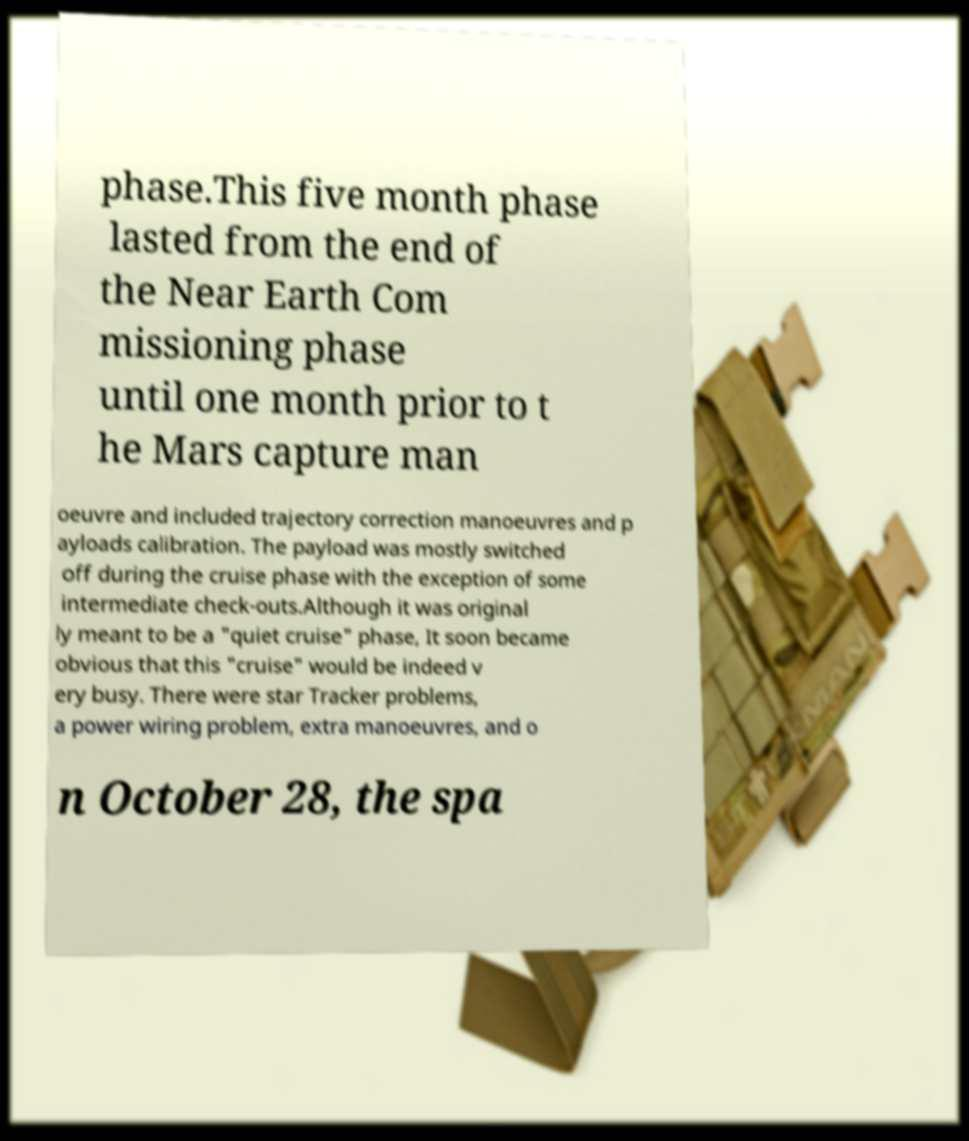Please read and relay the text visible in this image. What does it say? phase.This five month phase lasted from the end of the Near Earth Com missioning phase until one month prior to t he Mars capture man oeuvre and included trajectory correction manoeuvres and p ayloads calibration. The payload was mostly switched off during the cruise phase with the exception of some intermediate check-outs.Although it was original ly meant to be a "quiet cruise" phase, It soon became obvious that this "cruise" would be indeed v ery busy. There were star Tracker problems, a power wiring problem, extra manoeuvres, and o n October 28, the spa 